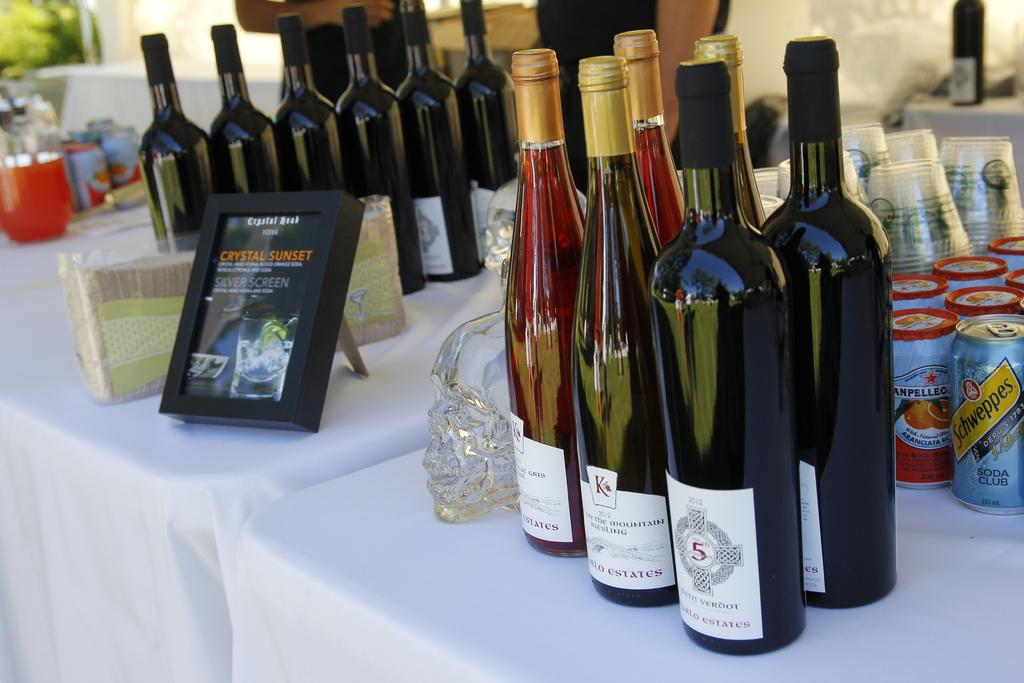<image>
Present a compact description of the photo's key features. A bunch of wine bottles on a table with a framed picture that says Crystal Sunset. 